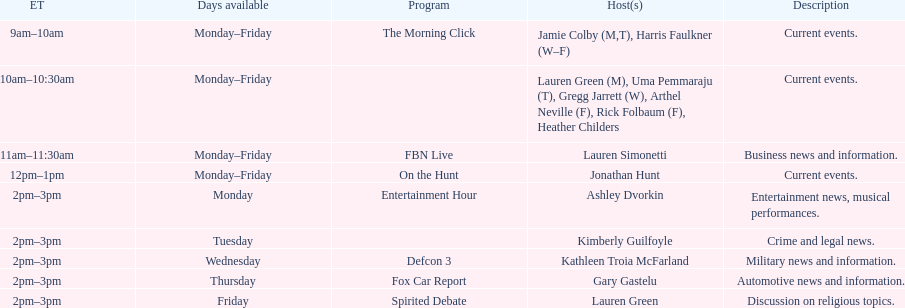Tell me who has her show on fridays at 2. Lauren Green. 